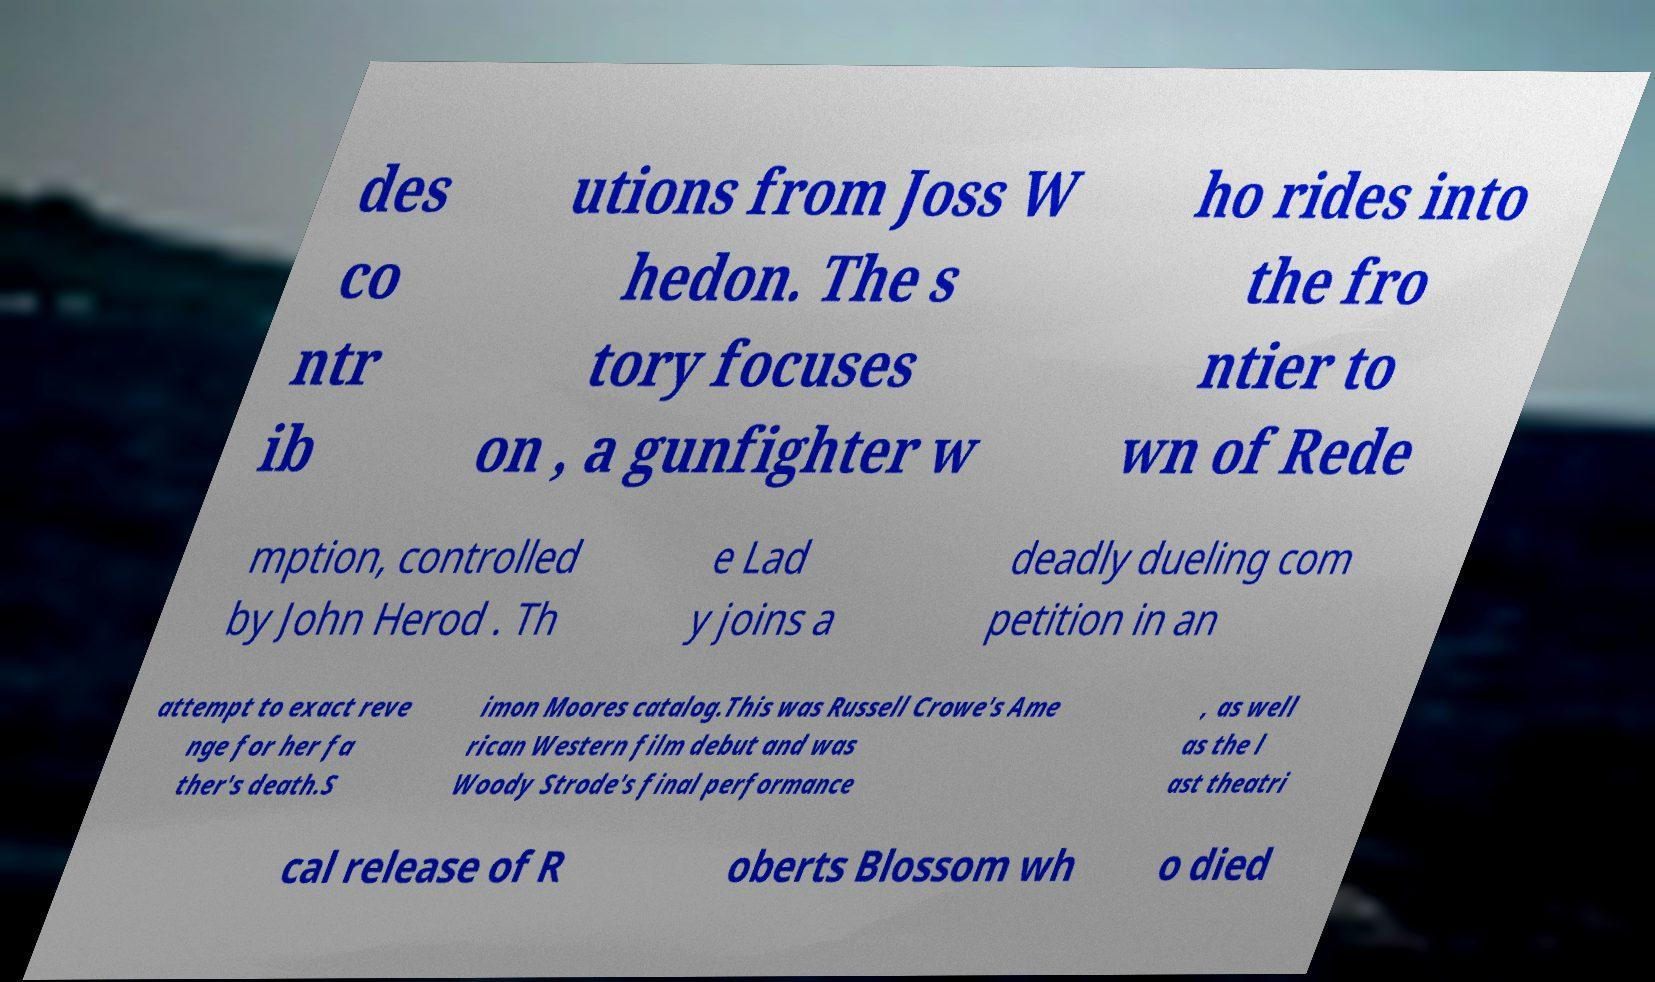Could you extract and type out the text from this image? des co ntr ib utions from Joss W hedon. The s tory focuses on , a gunfighter w ho rides into the fro ntier to wn of Rede mption, controlled by John Herod . Th e Lad y joins a deadly dueling com petition in an attempt to exact reve nge for her fa ther's death.S imon Moores catalog.This was Russell Crowe's Ame rican Western film debut and was Woody Strode's final performance , as well as the l ast theatri cal release of R oberts Blossom wh o died 